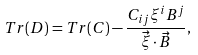<formula> <loc_0><loc_0><loc_500><loc_500>T r ( D ) = T r ( C ) - \frac { C _ { i j } \xi ^ { i } B ^ { j } } { \vec { \xi } \cdot \vec { B } } ,</formula> 